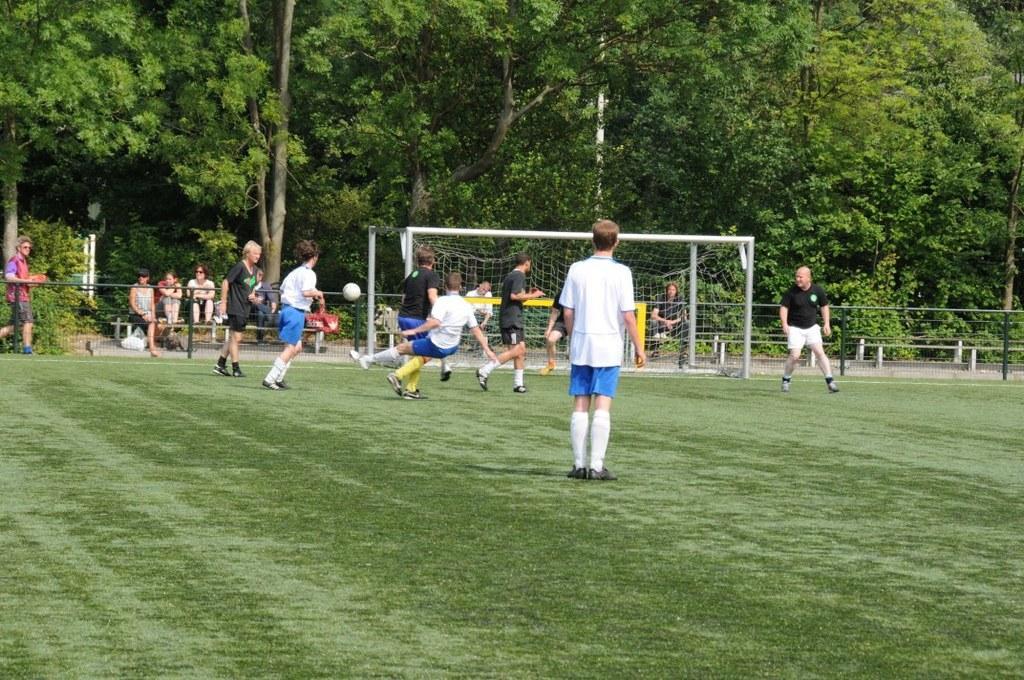Can you describe this image briefly? In the image we can see there are many people around standing, running and walking. They are wearing clothes, shoes and socks. Here we can see a ball, net court, grass, poles and trees. 